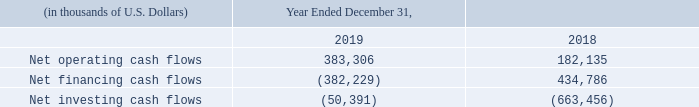The following table summarizes our consolidated cash and cash equivalents provided by (used for) operating, financing and investing activities for the periods presented:
Operating Cash Flows
Our consolidated net cash flow from operating activities fluctuates primarily as a result of changes in vessel utilization and TCE rates, changes in interest rates, fluctuations in working capital balances, the timing and amount of dry-docking expenditures, repairs and maintenance activities, vessel additions and dispositions, and foreign currency rates. Our exposure to the spot tanker market has contributed significantly to fluctuations in operating cash flows historically as a result of highly cyclical spot tanker rates.
In addition, the production performance of certain of our FPSO units that operate under contracts with a production-based compensation component has contributed to fluctuations in operating cash flows. As the charter contracts of some of our FPSO units include incentives based on average annual oil prices, the changes in global oil prices during recent years have also impacted our operating cash flows.
Consolidated net cash flow from operating activities increased to $383.3 million for the year ended December 31, 2019, from $182.1 million for the year ended December 31, 2018. This increase was primarily due to a $127.2 million increase in income from operations mainly from operations (before depreciation, amortization, asset impairments, loss on sale of vessels and the amortization of in-process revenue contracts) of our businesses.
For further discussion of changes in income from vessel operations from our businesses, please read “Item 5 – Operating and Financial Review and Prospects: Management’s Discussion and Analysis of Financial Condition and Results of Operations – Recent Developments and Results of Operations.”
In addition, there was a $9.9 million increase in cash flows from changes to non-cash working capital, a $23.6 million increase in dividends received from joint ventures, and a $17.1 million increase in direct financing lease payments received, which are presented as an operating cash inflow instead of an investing cash inflow after the adoption of ASU 2016-02 in 2019.
Furthermore, interest expense, including realized losses on interest rate swaps and cross currency swaps, decreased a net amount of $38.1 million for the year ended December 31, 2019 compared to 2018, primarily due to a decrease in realized losses on cross currency swaps. These increases were partially offset by an increase in cash outflows of $15.9 million in dry-dock expenditures for the year ended December 31, 2019, compared to 2018.
Financing Cash Flows
The Daughter Entities hold all of our liquefied gas carriers (Teekay LNG) and all of our conventional tanker assets (Teekay Tankers). Teekay LNG received $317.8 million of net proceeds from the sale-leaseback financing transactions for the Yamal Spirit and Torben Spirit for the year ended December 31, 2019, compared to $370.1 million from the sale-leaseback financing transactions completed for the Magdala, Myrina and Megara for the same period in 2018.
Teekay Tankers received $63.7 million from the sale-leaseback financing transactions completed on two of its Suezmax tankers for the year ended December 31, 2019, compared to $241.3 million in the same period last year from the sale-leaseback financing transactions completed on eight Aframax tankers, one Suezmax tanker and one LR2 Product tanker.
We use our credit facilities to partially finance capital expenditures. Occasionally, we will use revolving credit facilities to finance these expenditures until longer-term financing is obtained, at which time we typically use all or a portion of the proceeds from the longer-term financings to prepay outstanding amounts under the revolving credit facilities. We actively manage the maturity profile of our outstanding financing arrangements.
During 2019, we had a net cash outflow of $227.3 million relating primarily to prepayments of short-term and long-term debt, issuance costs and payments on maturity of cross currency swaps, net of proceeds from the issuances of short-term and long-term debt, compared to net cash inflow of $553.7 million in 2018. Scheduled repayments decreased by $438.1 million in 2019 compared to 2018.
Historically, the Daughter Entities have distributed operating cash flows to their owners in the form of distributions or dividends. There were no equity financing transactions from the Daughter Entities for the years ended December 31, 2019 and 2018. Teekay LNG repurchased $25.7 million of common units in the year ended December 31, 2019.
Teekay Parent did not raise capital through equity financing transactions in December 31, 2019, compared to $103.7 million raised in 2018 from issuances of new equity to the public, thirdparty investors and two entities established by our founder (including Resolute, our largest shareholder). Cash dividends paid decreased by $16.6 million in 2019, as a result of the elimination of Teekay Parent's quarterly dividend on Teekay’s common stock commencing with the quarter ended March 31, 2019.
Investing Cash Flows
During 2019, we received $100 million from Brookfield for the sale of our remaining interests in Altera (please read "Item 18 – Financial Statements: Note 4 – Deconsolidation and Sale of Altera"). We incurred capital expenditures for vessels and equipment of $109.5 million primarily for capitalized vessel modifications and shipyard construction installment payments in Teekay LNG.
Teekay LNG received proceeds of $11.5 million from the sale of the Alexander Spirit and contributed $72.4 million to its equity-accounted joint ventures and loans to joint ventures for the year ended December 31, 2019, primarily to fund project expenditures in the Yamal LNG Joint Venture and the Bahrain LNG Joint Venture. During 2019, Teekay Tankers received proceeds of $19.6 million related to the sale of one Suezmax tanker.
During 2018, we incurred capital expenditures for vessels and equipment of $0.7 billion, primarily for capitalized vessel modifications and shipyard construction installment payments. Teekay Parent advanced $25.0 million to Altera in the form of a senior unsecured revolving credit facility.
Teekay LNG received proceeds of $54.4 million from the sale of Teekay LNG's 50% ownership interest in the Excelsior Joint Venture and $28.5 million from the sales of the European Spirit and African Spirit. Teekay LNG contributed $40.5 million to its equityaccounted joint ventures and loans to joint ventures for the year ended December 31, 2018, primarily to fund project expenditures in the Yamal LNG Joint Venture, the Bahrain LNG project, and the Pan Union Joint Venture, and for working capital requirements for the MALT Joint Venture.
Teekay incurred a net $25.3 million cash outflow as a result of the 2017 Brookfield Transaction (please read "Item 18 – Financial Statements: Note 4 – Deconsolidation and Sale of Altera").
How much was Consolidated net cash flow from operating activities for the year ended December 31, 2019 and 2018? Consolidated net cash flow from operating activities increased to $383.3 million for the year ended december 31, 2019, from $182.1 million for the year ended december 31, 2018. What led to increase in Consolidated net cash flow from operating activities for the year ended December 31, 2019? This increase was primarily due to a $127.2 million increase in income from operations mainly from operations (before depreciation, amortization, asset impairments, loss on sale of vessels and the amortization of in-process revenue contracts) of our businesses. How much was received from Brookfield for the sale of interests in Altera during 2019? During 2019, we received $100 million from brookfield for the sale of our remaining interests in altera. What is the increase/ (decrease) in Net operating cash flows from Year Ended December 31, 2019 to December 31, 2018?
Answer scale should be: thousand. 383,306-182,135
Answer: 201171. What is the increase/ (decrease) in Net financing cash flows from Year Ended December 31, 2019 to December 31, 2018?
Answer scale should be: thousand. 382,229-434,786
Answer: -52557. What is the increase/ (decrease) in Net investing cash flows from Year Ended December 31, 2019 to December 31, 2018?
Answer scale should be: thousand. 50,391-663,456
Answer: -613065. 